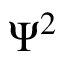Convert formula to latex. <formula><loc_0><loc_0><loc_500><loc_500>\Psi ^ { 2 }</formula> 